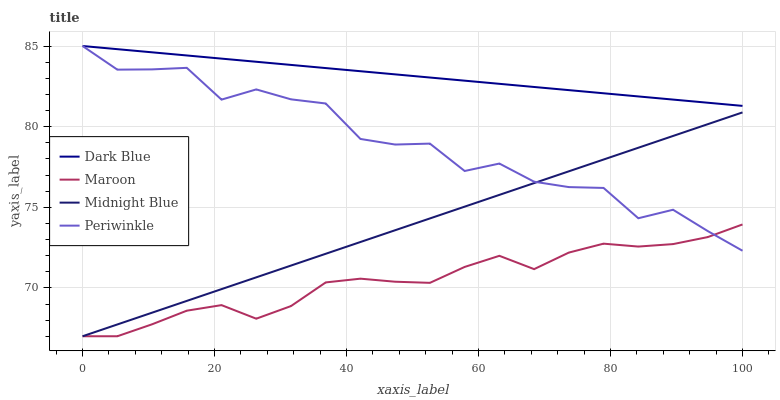Does Maroon have the minimum area under the curve?
Answer yes or no. Yes. Does Dark Blue have the maximum area under the curve?
Answer yes or no. Yes. Does Periwinkle have the minimum area under the curve?
Answer yes or no. No. Does Periwinkle have the maximum area under the curve?
Answer yes or no. No. Is Dark Blue the smoothest?
Answer yes or no. Yes. Is Periwinkle the roughest?
Answer yes or no. Yes. Is Midnight Blue the smoothest?
Answer yes or no. No. Is Midnight Blue the roughest?
Answer yes or no. No. Does Midnight Blue have the lowest value?
Answer yes or no. Yes. Does Periwinkle have the lowest value?
Answer yes or no. No. Does Periwinkle have the highest value?
Answer yes or no. Yes. Does Midnight Blue have the highest value?
Answer yes or no. No. Is Maroon less than Dark Blue?
Answer yes or no. Yes. Is Dark Blue greater than Midnight Blue?
Answer yes or no. Yes. Does Maroon intersect Midnight Blue?
Answer yes or no. Yes. Is Maroon less than Midnight Blue?
Answer yes or no. No. Is Maroon greater than Midnight Blue?
Answer yes or no. No. Does Maroon intersect Dark Blue?
Answer yes or no. No. 